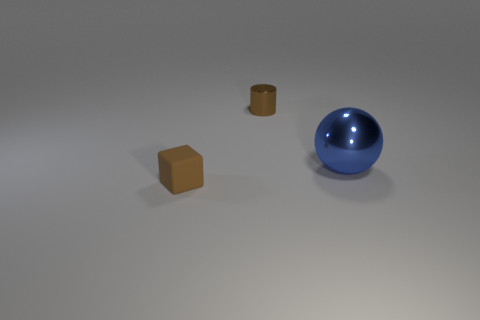Add 3 large spheres. How many objects exist? 6 Subtract all cubes. How many objects are left? 2 Add 2 tiny blocks. How many tiny blocks exist? 3 Subtract 1 brown cubes. How many objects are left? 2 Subtract all brown rubber things. Subtract all metal balls. How many objects are left? 1 Add 1 small matte blocks. How many small matte blocks are left? 2 